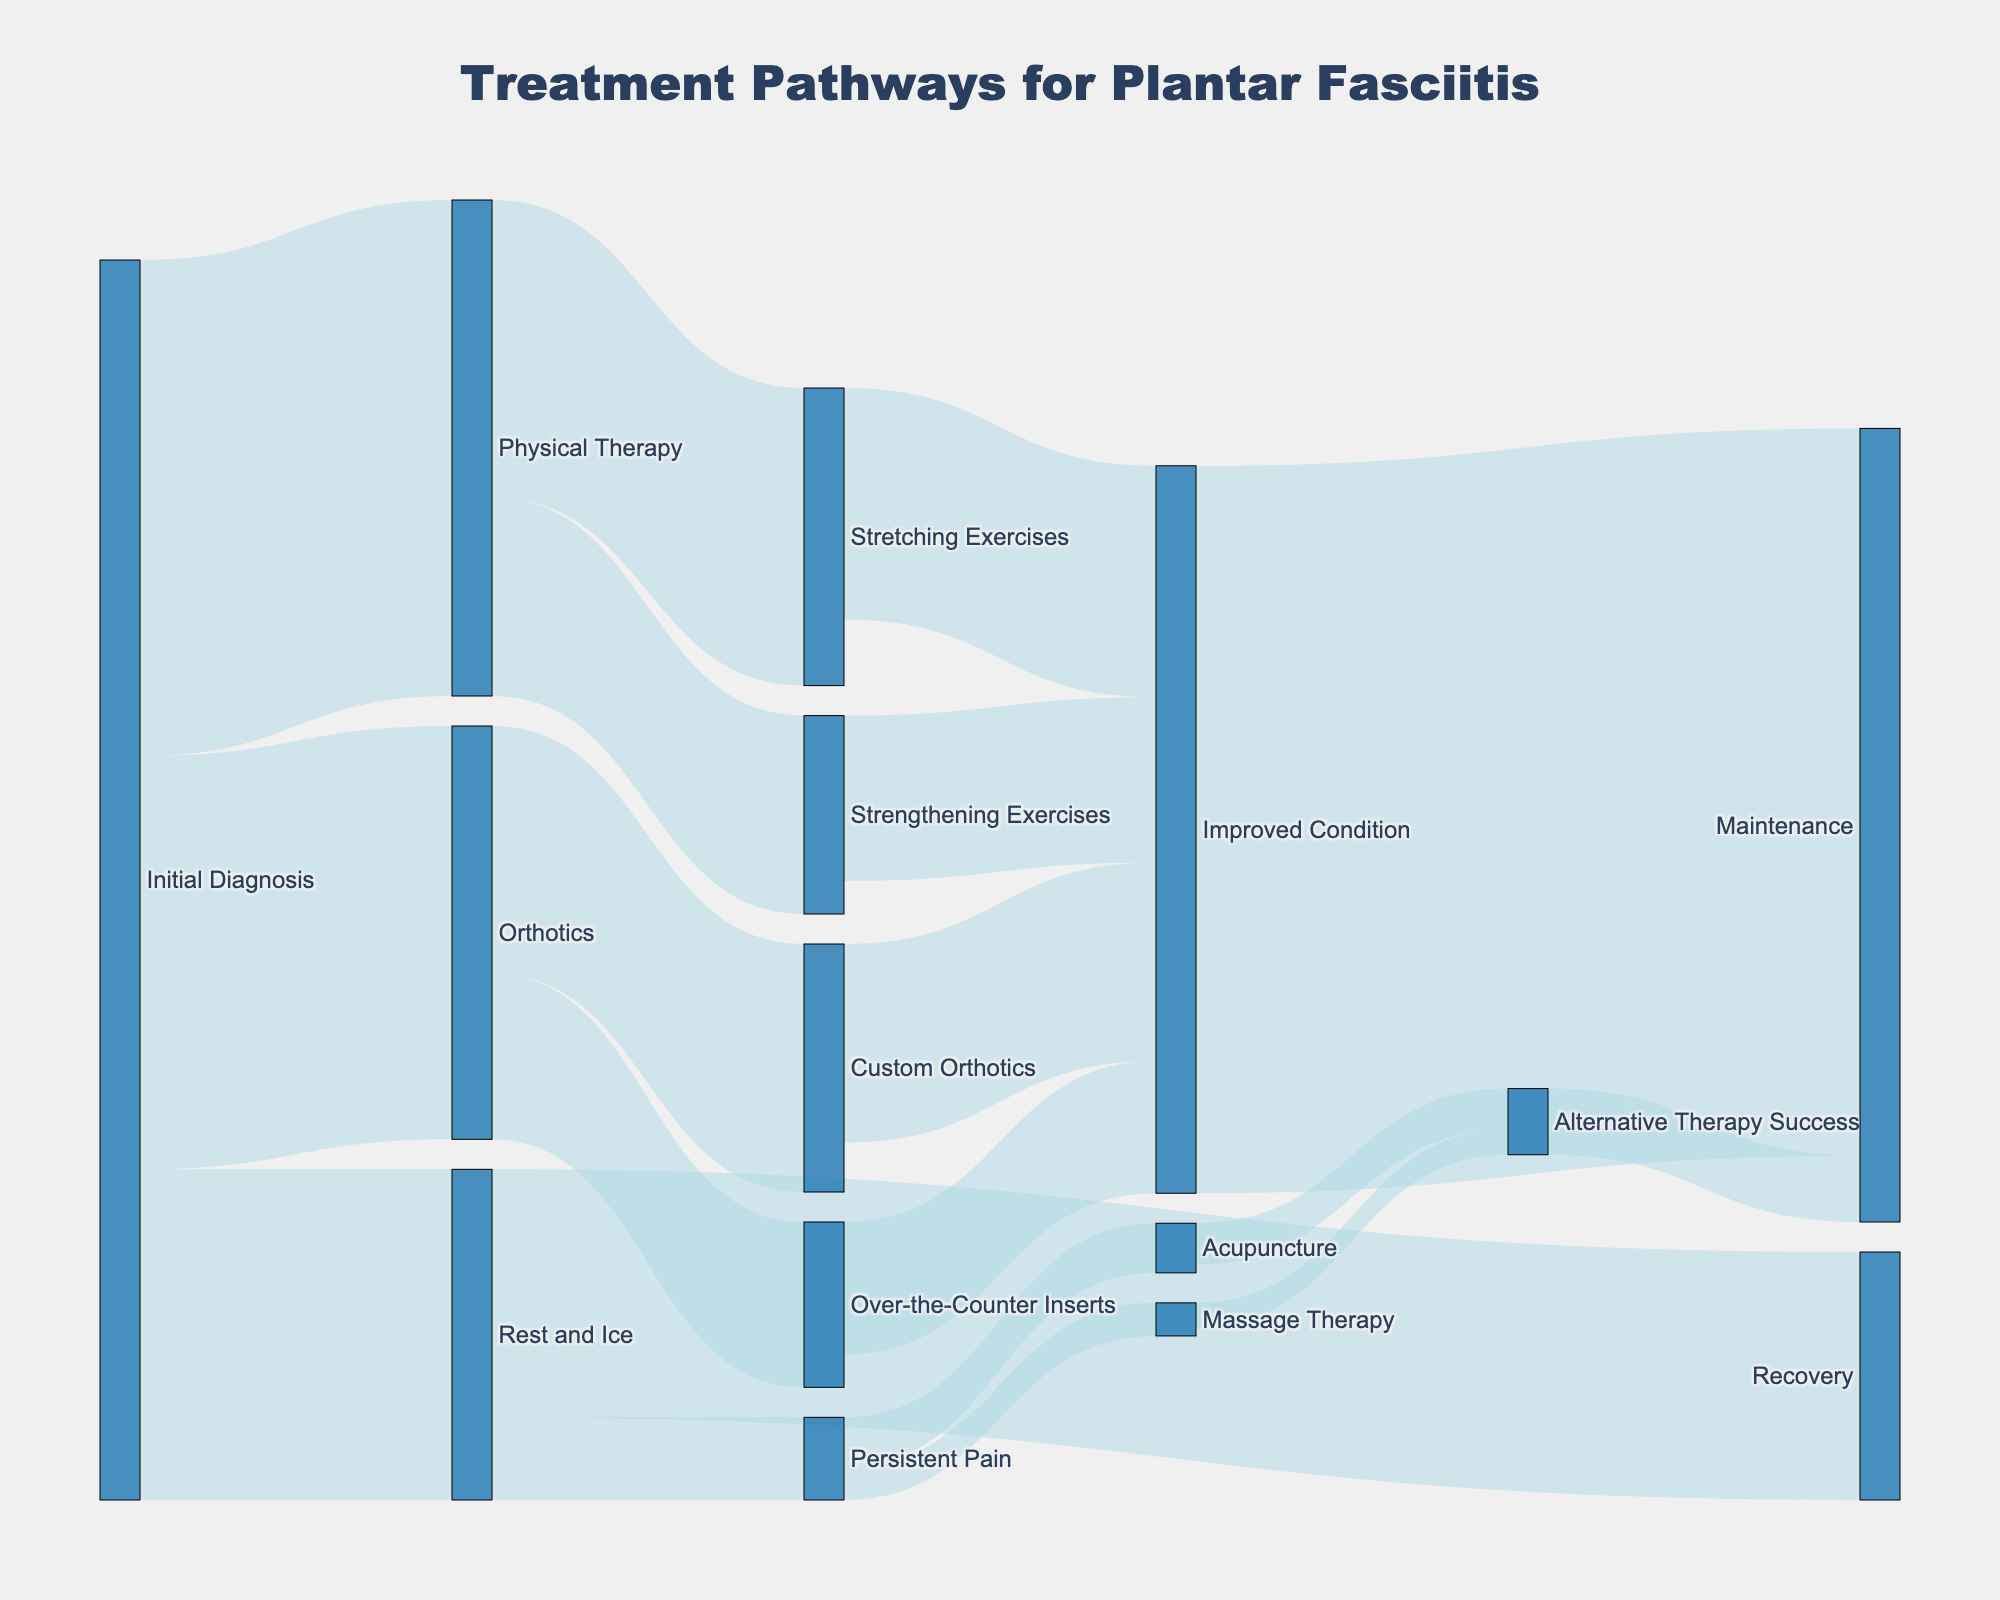What's the title of the figure? The title is usually located at the top of the figure, indicating the main topic or subject of the visualized data. Here, the title clearly specifies what the Sankey diagram represents.
Answer: Treatment Pathways for Plantar Fasciitis How many patients received Physical Therapy as a first-line treatment? Check the flow from the 'Initial Diagnosis' node to the 'Physical Therapy' node. The value connected to these nodes gives the number of patients.
Answer: 300 Which alternative therapy resulted in the most maintenance cases? To answer this, observe the flow connections leading to the 'Maintenance' node and identify which preceding node (current therapies) sends the largest number of patients.
Answer: Improved Condition What proportion of patients improved their condition through Stretching Exercises? First, find the value flowing from 'Stretching Exercises' to 'Improved Condition'. Then, correlate it against the total patients at 'Stretching Exercises.'
Answer: 140 out of 180 How many patients ended up in maintenance after improving their condition? Look for the flow from 'Improved Condition' to 'Maintenance' to find this answer in the diagram.
Answer: 440 Which pathway had the least patients progressing to alternative therapies like Acupuncture or Massage Therapy? Inspect the connections leading to 'Acupuncture' and 'Massage Therapy.' Compare these values to see where fewer patients progress to these treatments.
Answer: Massage Therapy How many total patients started with orthotics? Sum the values flowing from 'Initial Diagnosis' to 'Orthotics.'
Answer: 250 Compare the number of patients who used Custom Orthotics vs. Over-the-Counter Inserts and improved their condition. Identify the values flowing from 'Custom Orthotics' and 'Over-the-Counter Inserts' to 'Improved Condition' and compare them.
Answer: Custom Orthotics (120) vs. Over-the-Counter Inserts (80) What's the total number of patients receiving all types of alternative therapies for Persistent Pain? Sum the values flowing from 'Persistent Pain' to 'Acupuncture' and 'Massage Therapy.'
Answer: 30 + 20 = 50 